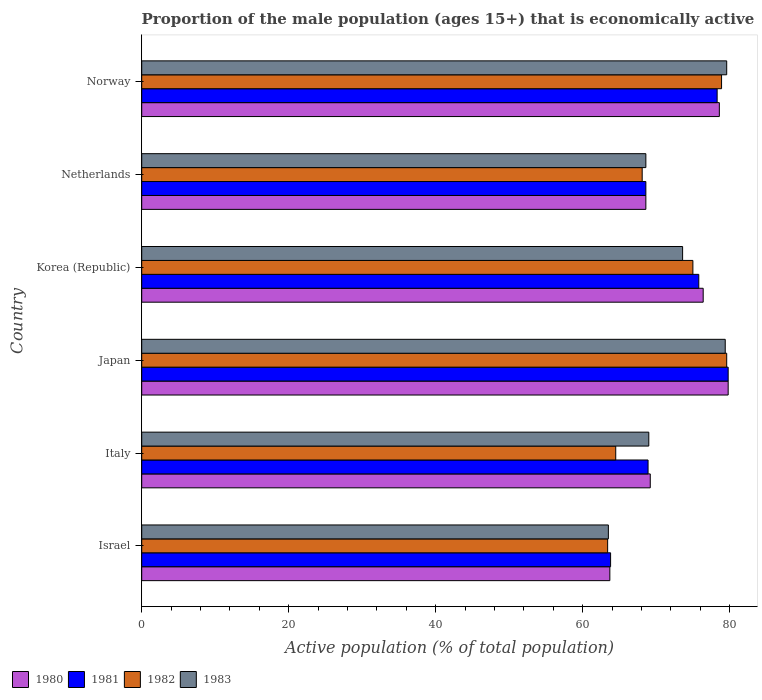How many different coloured bars are there?
Offer a very short reply. 4. Are the number of bars on each tick of the Y-axis equal?
Your answer should be compact. Yes. How many bars are there on the 3rd tick from the top?
Your response must be concise. 4. How many bars are there on the 1st tick from the bottom?
Give a very brief answer. 4. In how many cases, is the number of bars for a given country not equal to the number of legend labels?
Your response must be concise. 0. Across all countries, what is the maximum proportion of the male population that is economically active in 1982?
Give a very brief answer. 79.6. Across all countries, what is the minimum proportion of the male population that is economically active in 1982?
Provide a succinct answer. 63.4. In which country was the proportion of the male population that is economically active in 1983 maximum?
Your response must be concise. Norway. In which country was the proportion of the male population that is economically active in 1982 minimum?
Ensure brevity in your answer.  Israel. What is the total proportion of the male population that is economically active in 1983 in the graph?
Offer a very short reply. 433.7. What is the difference between the proportion of the male population that is economically active in 1980 in Japan and that in Korea (Republic)?
Make the answer very short. 3.4. What is the difference between the proportion of the male population that is economically active in 1981 in Israel and the proportion of the male population that is economically active in 1980 in Norway?
Provide a succinct answer. -14.8. What is the average proportion of the male population that is economically active in 1981 per country?
Your answer should be very brief. 72.53. In how many countries, is the proportion of the male population that is economically active in 1981 greater than 4 %?
Give a very brief answer. 6. What is the ratio of the proportion of the male population that is economically active in 1981 in Netherlands to that in Norway?
Make the answer very short. 0.88. Is the difference between the proportion of the male population that is economically active in 1980 in Israel and Italy greater than the difference between the proportion of the male population that is economically active in 1982 in Israel and Italy?
Provide a succinct answer. No. What is the difference between the highest and the second highest proportion of the male population that is economically active in 1980?
Your response must be concise. 1.2. What is the difference between the highest and the lowest proportion of the male population that is economically active in 1980?
Offer a terse response. 16.1. In how many countries, is the proportion of the male population that is economically active in 1983 greater than the average proportion of the male population that is economically active in 1983 taken over all countries?
Offer a very short reply. 3. Is the sum of the proportion of the male population that is economically active in 1982 in Italy and Japan greater than the maximum proportion of the male population that is economically active in 1981 across all countries?
Offer a terse response. Yes. Is it the case that in every country, the sum of the proportion of the male population that is economically active in 1981 and proportion of the male population that is economically active in 1980 is greater than the sum of proportion of the male population that is economically active in 1982 and proportion of the male population that is economically active in 1983?
Your response must be concise. No. Are all the bars in the graph horizontal?
Provide a succinct answer. Yes. What is the title of the graph?
Offer a terse response. Proportion of the male population (ages 15+) that is economically active. What is the label or title of the X-axis?
Keep it short and to the point. Active population (% of total population). What is the Active population (% of total population) in 1980 in Israel?
Your response must be concise. 63.7. What is the Active population (% of total population) in 1981 in Israel?
Your answer should be compact. 63.8. What is the Active population (% of total population) of 1982 in Israel?
Ensure brevity in your answer.  63.4. What is the Active population (% of total population) of 1983 in Israel?
Keep it short and to the point. 63.5. What is the Active population (% of total population) of 1980 in Italy?
Provide a short and direct response. 69.2. What is the Active population (% of total population) in 1981 in Italy?
Give a very brief answer. 68.9. What is the Active population (% of total population) of 1982 in Italy?
Keep it short and to the point. 64.5. What is the Active population (% of total population) of 1983 in Italy?
Your answer should be very brief. 69. What is the Active population (% of total population) of 1980 in Japan?
Your response must be concise. 79.8. What is the Active population (% of total population) in 1981 in Japan?
Give a very brief answer. 79.8. What is the Active population (% of total population) in 1982 in Japan?
Your answer should be very brief. 79.6. What is the Active population (% of total population) in 1983 in Japan?
Keep it short and to the point. 79.4. What is the Active population (% of total population) in 1980 in Korea (Republic)?
Make the answer very short. 76.4. What is the Active population (% of total population) in 1981 in Korea (Republic)?
Offer a very short reply. 75.8. What is the Active population (% of total population) in 1983 in Korea (Republic)?
Offer a terse response. 73.6. What is the Active population (% of total population) in 1980 in Netherlands?
Provide a succinct answer. 68.6. What is the Active population (% of total population) of 1981 in Netherlands?
Your answer should be compact. 68.6. What is the Active population (% of total population) of 1982 in Netherlands?
Offer a very short reply. 68.1. What is the Active population (% of total population) in 1983 in Netherlands?
Provide a short and direct response. 68.6. What is the Active population (% of total population) in 1980 in Norway?
Ensure brevity in your answer.  78.6. What is the Active population (% of total population) in 1981 in Norway?
Make the answer very short. 78.3. What is the Active population (% of total population) of 1982 in Norway?
Offer a very short reply. 78.9. What is the Active population (% of total population) of 1983 in Norway?
Your response must be concise. 79.6. Across all countries, what is the maximum Active population (% of total population) in 1980?
Your answer should be very brief. 79.8. Across all countries, what is the maximum Active population (% of total population) of 1981?
Make the answer very short. 79.8. Across all countries, what is the maximum Active population (% of total population) of 1982?
Keep it short and to the point. 79.6. Across all countries, what is the maximum Active population (% of total population) in 1983?
Provide a short and direct response. 79.6. Across all countries, what is the minimum Active population (% of total population) in 1980?
Give a very brief answer. 63.7. Across all countries, what is the minimum Active population (% of total population) of 1981?
Your answer should be compact. 63.8. Across all countries, what is the minimum Active population (% of total population) in 1982?
Your response must be concise. 63.4. Across all countries, what is the minimum Active population (% of total population) of 1983?
Make the answer very short. 63.5. What is the total Active population (% of total population) of 1980 in the graph?
Provide a succinct answer. 436.3. What is the total Active population (% of total population) in 1981 in the graph?
Provide a succinct answer. 435.2. What is the total Active population (% of total population) of 1982 in the graph?
Offer a terse response. 429.5. What is the total Active population (% of total population) in 1983 in the graph?
Offer a very short reply. 433.7. What is the difference between the Active population (% of total population) in 1980 in Israel and that in Italy?
Keep it short and to the point. -5.5. What is the difference between the Active population (% of total population) in 1983 in Israel and that in Italy?
Offer a terse response. -5.5. What is the difference between the Active population (% of total population) of 1980 in Israel and that in Japan?
Make the answer very short. -16.1. What is the difference between the Active population (% of total population) of 1981 in Israel and that in Japan?
Offer a very short reply. -16. What is the difference between the Active population (% of total population) of 1982 in Israel and that in Japan?
Make the answer very short. -16.2. What is the difference between the Active population (% of total population) in 1983 in Israel and that in Japan?
Ensure brevity in your answer.  -15.9. What is the difference between the Active population (% of total population) in 1981 in Israel and that in Korea (Republic)?
Offer a very short reply. -12. What is the difference between the Active population (% of total population) in 1983 in Israel and that in Korea (Republic)?
Provide a succinct answer. -10.1. What is the difference between the Active population (% of total population) of 1983 in Israel and that in Netherlands?
Offer a very short reply. -5.1. What is the difference between the Active population (% of total population) in 1980 in Israel and that in Norway?
Give a very brief answer. -14.9. What is the difference between the Active population (% of total population) in 1982 in Israel and that in Norway?
Your response must be concise. -15.5. What is the difference between the Active population (% of total population) in 1983 in Israel and that in Norway?
Provide a short and direct response. -16.1. What is the difference between the Active population (% of total population) of 1980 in Italy and that in Japan?
Keep it short and to the point. -10.6. What is the difference between the Active population (% of total population) of 1982 in Italy and that in Japan?
Provide a succinct answer. -15.1. What is the difference between the Active population (% of total population) of 1980 in Italy and that in Korea (Republic)?
Provide a short and direct response. -7.2. What is the difference between the Active population (% of total population) of 1981 in Italy and that in Korea (Republic)?
Provide a succinct answer. -6.9. What is the difference between the Active population (% of total population) of 1983 in Italy and that in Korea (Republic)?
Offer a terse response. -4.6. What is the difference between the Active population (% of total population) in 1980 in Italy and that in Netherlands?
Give a very brief answer. 0.6. What is the difference between the Active population (% of total population) of 1982 in Italy and that in Netherlands?
Provide a succinct answer. -3.6. What is the difference between the Active population (% of total population) of 1983 in Italy and that in Netherlands?
Your answer should be very brief. 0.4. What is the difference between the Active population (% of total population) in 1980 in Italy and that in Norway?
Your answer should be compact. -9.4. What is the difference between the Active population (% of total population) in 1981 in Italy and that in Norway?
Give a very brief answer. -9.4. What is the difference between the Active population (% of total population) in 1982 in Italy and that in Norway?
Make the answer very short. -14.4. What is the difference between the Active population (% of total population) in 1980 in Japan and that in Korea (Republic)?
Your answer should be very brief. 3.4. What is the difference between the Active population (% of total population) in 1981 in Japan and that in Korea (Republic)?
Your answer should be very brief. 4. What is the difference between the Active population (% of total population) in 1982 in Japan and that in Korea (Republic)?
Keep it short and to the point. 4.6. What is the difference between the Active population (% of total population) of 1983 in Japan and that in Korea (Republic)?
Provide a short and direct response. 5.8. What is the difference between the Active population (% of total population) in 1980 in Japan and that in Netherlands?
Provide a short and direct response. 11.2. What is the difference between the Active population (% of total population) of 1982 in Japan and that in Netherlands?
Provide a succinct answer. 11.5. What is the difference between the Active population (% of total population) of 1983 in Japan and that in Netherlands?
Your response must be concise. 10.8. What is the difference between the Active population (% of total population) in 1981 in Japan and that in Norway?
Give a very brief answer. 1.5. What is the difference between the Active population (% of total population) in 1983 in Japan and that in Norway?
Offer a very short reply. -0.2. What is the difference between the Active population (% of total population) in 1980 in Korea (Republic) and that in Netherlands?
Provide a succinct answer. 7.8. What is the difference between the Active population (% of total population) of 1981 in Korea (Republic) and that in Netherlands?
Ensure brevity in your answer.  7.2. What is the difference between the Active population (% of total population) of 1982 in Korea (Republic) and that in Netherlands?
Offer a terse response. 6.9. What is the difference between the Active population (% of total population) in 1981 in Korea (Republic) and that in Norway?
Give a very brief answer. -2.5. What is the difference between the Active population (% of total population) in 1980 in Netherlands and that in Norway?
Offer a terse response. -10. What is the difference between the Active population (% of total population) in 1980 in Israel and the Active population (% of total population) in 1981 in Italy?
Give a very brief answer. -5.2. What is the difference between the Active population (% of total population) in 1980 in Israel and the Active population (% of total population) in 1982 in Italy?
Ensure brevity in your answer.  -0.8. What is the difference between the Active population (% of total population) in 1980 in Israel and the Active population (% of total population) in 1983 in Italy?
Provide a succinct answer. -5.3. What is the difference between the Active population (% of total population) of 1981 in Israel and the Active population (% of total population) of 1982 in Italy?
Offer a terse response. -0.7. What is the difference between the Active population (% of total population) of 1981 in Israel and the Active population (% of total population) of 1983 in Italy?
Ensure brevity in your answer.  -5.2. What is the difference between the Active population (% of total population) in 1980 in Israel and the Active population (% of total population) in 1981 in Japan?
Offer a terse response. -16.1. What is the difference between the Active population (% of total population) in 1980 in Israel and the Active population (% of total population) in 1982 in Japan?
Provide a succinct answer. -15.9. What is the difference between the Active population (% of total population) in 1980 in Israel and the Active population (% of total population) in 1983 in Japan?
Provide a short and direct response. -15.7. What is the difference between the Active population (% of total population) of 1981 in Israel and the Active population (% of total population) of 1982 in Japan?
Your answer should be compact. -15.8. What is the difference between the Active population (% of total population) of 1981 in Israel and the Active population (% of total population) of 1983 in Japan?
Your answer should be very brief. -15.6. What is the difference between the Active population (% of total population) of 1980 in Israel and the Active population (% of total population) of 1982 in Korea (Republic)?
Your answer should be compact. -11.3. What is the difference between the Active population (% of total population) in 1981 in Israel and the Active population (% of total population) in 1982 in Korea (Republic)?
Provide a short and direct response. -11.2. What is the difference between the Active population (% of total population) in 1980 in Israel and the Active population (% of total population) in 1981 in Netherlands?
Your answer should be compact. -4.9. What is the difference between the Active population (% of total population) of 1981 in Israel and the Active population (% of total population) of 1982 in Netherlands?
Provide a short and direct response. -4.3. What is the difference between the Active population (% of total population) of 1981 in Israel and the Active population (% of total population) of 1983 in Netherlands?
Provide a succinct answer. -4.8. What is the difference between the Active population (% of total population) in 1982 in Israel and the Active population (% of total population) in 1983 in Netherlands?
Keep it short and to the point. -5.2. What is the difference between the Active population (% of total population) in 1980 in Israel and the Active population (% of total population) in 1981 in Norway?
Your answer should be very brief. -14.6. What is the difference between the Active population (% of total population) in 1980 in Israel and the Active population (% of total population) in 1982 in Norway?
Provide a succinct answer. -15.2. What is the difference between the Active population (% of total population) of 1980 in Israel and the Active population (% of total population) of 1983 in Norway?
Provide a short and direct response. -15.9. What is the difference between the Active population (% of total population) in 1981 in Israel and the Active population (% of total population) in 1982 in Norway?
Your answer should be very brief. -15.1. What is the difference between the Active population (% of total population) of 1981 in Israel and the Active population (% of total population) of 1983 in Norway?
Ensure brevity in your answer.  -15.8. What is the difference between the Active population (% of total population) in 1982 in Israel and the Active population (% of total population) in 1983 in Norway?
Your answer should be very brief. -16.2. What is the difference between the Active population (% of total population) of 1980 in Italy and the Active population (% of total population) of 1981 in Japan?
Provide a short and direct response. -10.6. What is the difference between the Active population (% of total population) in 1982 in Italy and the Active population (% of total population) in 1983 in Japan?
Offer a very short reply. -14.9. What is the difference between the Active population (% of total population) of 1980 in Italy and the Active population (% of total population) of 1981 in Korea (Republic)?
Offer a very short reply. -6.6. What is the difference between the Active population (% of total population) of 1980 in Italy and the Active population (% of total population) of 1982 in Korea (Republic)?
Your response must be concise. -5.8. What is the difference between the Active population (% of total population) in 1980 in Italy and the Active population (% of total population) in 1983 in Korea (Republic)?
Your answer should be compact. -4.4. What is the difference between the Active population (% of total population) of 1981 in Italy and the Active population (% of total population) of 1983 in Korea (Republic)?
Keep it short and to the point. -4.7. What is the difference between the Active population (% of total population) of 1982 in Italy and the Active population (% of total population) of 1983 in Korea (Republic)?
Provide a succinct answer. -9.1. What is the difference between the Active population (% of total population) in 1980 in Italy and the Active population (% of total population) in 1981 in Netherlands?
Make the answer very short. 0.6. What is the difference between the Active population (% of total population) of 1981 in Italy and the Active population (% of total population) of 1983 in Netherlands?
Your response must be concise. 0.3. What is the difference between the Active population (% of total population) of 1980 in Italy and the Active population (% of total population) of 1981 in Norway?
Your answer should be compact. -9.1. What is the difference between the Active population (% of total population) in 1980 in Italy and the Active population (% of total population) in 1983 in Norway?
Provide a short and direct response. -10.4. What is the difference between the Active population (% of total population) in 1981 in Italy and the Active population (% of total population) in 1983 in Norway?
Give a very brief answer. -10.7. What is the difference between the Active population (% of total population) of 1982 in Italy and the Active population (% of total population) of 1983 in Norway?
Keep it short and to the point. -15.1. What is the difference between the Active population (% of total population) of 1980 in Japan and the Active population (% of total population) of 1981 in Korea (Republic)?
Offer a very short reply. 4. What is the difference between the Active population (% of total population) in 1980 in Japan and the Active population (% of total population) in 1982 in Korea (Republic)?
Your response must be concise. 4.8. What is the difference between the Active population (% of total population) in 1980 in Japan and the Active population (% of total population) in 1983 in Korea (Republic)?
Give a very brief answer. 6.2. What is the difference between the Active population (% of total population) of 1981 in Japan and the Active population (% of total population) of 1982 in Korea (Republic)?
Provide a short and direct response. 4.8. What is the difference between the Active population (% of total population) of 1981 in Japan and the Active population (% of total population) of 1983 in Korea (Republic)?
Provide a short and direct response. 6.2. What is the difference between the Active population (% of total population) of 1982 in Japan and the Active population (% of total population) of 1983 in Korea (Republic)?
Provide a short and direct response. 6. What is the difference between the Active population (% of total population) of 1980 in Japan and the Active population (% of total population) of 1981 in Netherlands?
Offer a terse response. 11.2. What is the difference between the Active population (% of total population) in 1980 in Japan and the Active population (% of total population) in 1982 in Netherlands?
Your response must be concise. 11.7. What is the difference between the Active population (% of total population) in 1980 in Japan and the Active population (% of total population) in 1983 in Netherlands?
Make the answer very short. 11.2. What is the difference between the Active population (% of total population) in 1981 in Japan and the Active population (% of total population) in 1982 in Netherlands?
Provide a succinct answer. 11.7. What is the difference between the Active population (% of total population) of 1980 in Japan and the Active population (% of total population) of 1981 in Norway?
Provide a short and direct response. 1.5. What is the difference between the Active population (% of total population) of 1980 in Japan and the Active population (% of total population) of 1982 in Norway?
Give a very brief answer. 0.9. What is the difference between the Active population (% of total population) of 1981 in Japan and the Active population (% of total population) of 1982 in Norway?
Make the answer very short. 0.9. What is the difference between the Active population (% of total population) in 1981 in Japan and the Active population (% of total population) in 1983 in Norway?
Ensure brevity in your answer.  0.2. What is the difference between the Active population (% of total population) in 1982 in Japan and the Active population (% of total population) in 1983 in Norway?
Ensure brevity in your answer.  0. What is the difference between the Active population (% of total population) in 1980 in Korea (Republic) and the Active population (% of total population) in 1981 in Netherlands?
Make the answer very short. 7.8. What is the difference between the Active population (% of total population) in 1981 in Korea (Republic) and the Active population (% of total population) in 1983 in Netherlands?
Offer a terse response. 7.2. What is the difference between the Active population (% of total population) of 1980 in Korea (Republic) and the Active population (% of total population) of 1981 in Norway?
Make the answer very short. -1.9. What is the difference between the Active population (% of total population) of 1980 in Netherlands and the Active population (% of total population) of 1982 in Norway?
Your answer should be compact. -10.3. What is the difference between the Active population (% of total population) in 1982 in Netherlands and the Active population (% of total population) in 1983 in Norway?
Make the answer very short. -11.5. What is the average Active population (% of total population) of 1980 per country?
Your answer should be compact. 72.72. What is the average Active population (% of total population) of 1981 per country?
Your response must be concise. 72.53. What is the average Active population (% of total population) of 1982 per country?
Your response must be concise. 71.58. What is the average Active population (% of total population) in 1983 per country?
Offer a very short reply. 72.28. What is the difference between the Active population (% of total population) of 1981 and Active population (% of total population) of 1983 in Israel?
Offer a very short reply. 0.3. What is the difference between the Active population (% of total population) of 1982 and Active population (% of total population) of 1983 in Israel?
Your answer should be very brief. -0.1. What is the difference between the Active population (% of total population) of 1980 and Active population (% of total population) of 1982 in Italy?
Ensure brevity in your answer.  4.7. What is the difference between the Active population (% of total population) of 1980 and Active population (% of total population) of 1983 in Italy?
Keep it short and to the point. 0.2. What is the difference between the Active population (% of total population) of 1982 and Active population (% of total population) of 1983 in Italy?
Make the answer very short. -4.5. What is the difference between the Active population (% of total population) of 1980 and Active population (% of total population) of 1981 in Japan?
Make the answer very short. 0. What is the difference between the Active population (% of total population) in 1980 and Active population (% of total population) in 1983 in Japan?
Keep it short and to the point. 0.4. What is the difference between the Active population (% of total population) in 1981 and Active population (% of total population) in 1982 in Japan?
Your response must be concise. 0.2. What is the difference between the Active population (% of total population) in 1982 and Active population (% of total population) in 1983 in Japan?
Keep it short and to the point. 0.2. What is the difference between the Active population (% of total population) in 1981 and Active population (% of total population) in 1983 in Korea (Republic)?
Ensure brevity in your answer.  2.2. What is the difference between the Active population (% of total population) in 1980 and Active population (% of total population) in 1981 in Netherlands?
Provide a succinct answer. 0. What is the difference between the Active population (% of total population) in 1980 and Active population (% of total population) in 1982 in Netherlands?
Your answer should be compact. 0.5. What is the difference between the Active population (% of total population) of 1981 and Active population (% of total population) of 1982 in Netherlands?
Give a very brief answer. 0.5. What is the difference between the Active population (% of total population) in 1982 and Active population (% of total population) in 1983 in Netherlands?
Offer a terse response. -0.5. What is the difference between the Active population (% of total population) in 1980 and Active population (% of total population) in 1981 in Norway?
Your answer should be compact. 0.3. What is the difference between the Active population (% of total population) in 1981 and Active population (% of total population) in 1983 in Norway?
Ensure brevity in your answer.  -1.3. What is the difference between the Active population (% of total population) in 1982 and Active population (% of total population) in 1983 in Norway?
Your answer should be very brief. -0.7. What is the ratio of the Active population (% of total population) in 1980 in Israel to that in Italy?
Your answer should be compact. 0.92. What is the ratio of the Active population (% of total population) in 1981 in Israel to that in Italy?
Offer a terse response. 0.93. What is the ratio of the Active population (% of total population) of 1982 in Israel to that in Italy?
Give a very brief answer. 0.98. What is the ratio of the Active population (% of total population) of 1983 in Israel to that in Italy?
Give a very brief answer. 0.92. What is the ratio of the Active population (% of total population) in 1980 in Israel to that in Japan?
Keep it short and to the point. 0.8. What is the ratio of the Active population (% of total population) of 1981 in Israel to that in Japan?
Keep it short and to the point. 0.8. What is the ratio of the Active population (% of total population) of 1982 in Israel to that in Japan?
Your response must be concise. 0.8. What is the ratio of the Active population (% of total population) of 1983 in Israel to that in Japan?
Provide a succinct answer. 0.8. What is the ratio of the Active population (% of total population) in 1980 in Israel to that in Korea (Republic)?
Give a very brief answer. 0.83. What is the ratio of the Active population (% of total population) in 1981 in Israel to that in Korea (Republic)?
Keep it short and to the point. 0.84. What is the ratio of the Active population (% of total population) of 1982 in Israel to that in Korea (Republic)?
Ensure brevity in your answer.  0.85. What is the ratio of the Active population (% of total population) of 1983 in Israel to that in Korea (Republic)?
Offer a very short reply. 0.86. What is the ratio of the Active population (% of total population) of 1983 in Israel to that in Netherlands?
Provide a succinct answer. 0.93. What is the ratio of the Active population (% of total population) in 1980 in Israel to that in Norway?
Your response must be concise. 0.81. What is the ratio of the Active population (% of total population) in 1981 in Israel to that in Norway?
Your answer should be compact. 0.81. What is the ratio of the Active population (% of total population) in 1982 in Israel to that in Norway?
Your response must be concise. 0.8. What is the ratio of the Active population (% of total population) in 1983 in Israel to that in Norway?
Offer a very short reply. 0.8. What is the ratio of the Active population (% of total population) of 1980 in Italy to that in Japan?
Give a very brief answer. 0.87. What is the ratio of the Active population (% of total population) in 1981 in Italy to that in Japan?
Make the answer very short. 0.86. What is the ratio of the Active population (% of total population) in 1982 in Italy to that in Japan?
Make the answer very short. 0.81. What is the ratio of the Active population (% of total population) of 1983 in Italy to that in Japan?
Keep it short and to the point. 0.87. What is the ratio of the Active population (% of total population) of 1980 in Italy to that in Korea (Republic)?
Offer a terse response. 0.91. What is the ratio of the Active population (% of total population) of 1981 in Italy to that in Korea (Republic)?
Offer a very short reply. 0.91. What is the ratio of the Active population (% of total population) in 1982 in Italy to that in Korea (Republic)?
Ensure brevity in your answer.  0.86. What is the ratio of the Active population (% of total population) in 1983 in Italy to that in Korea (Republic)?
Your response must be concise. 0.94. What is the ratio of the Active population (% of total population) of 1980 in Italy to that in Netherlands?
Your answer should be compact. 1.01. What is the ratio of the Active population (% of total population) in 1981 in Italy to that in Netherlands?
Provide a succinct answer. 1. What is the ratio of the Active population (% of total population) of 1982 in Italy to that in Netherlands?
Provide a succinct answer. 0.95. What is the ratio of the Active population (% of total population) of 1983 in Italy to that in Netherlands?
Your answer should be compact. 1.01. What is the ratio of the Active population (% of total population) of 1980 in Italy to that in Norway?
Your answer should be compact. 0.88. What is the ratio of the Active population (% of total population) of 1981 in Italy to that in Norway?
Provide a short and direct response. 0.88. What is the ratio of the Active population (% of total population) of 1982 in Italy to that in Norway?
Offer a terse response. 0.82. What is the ratio of the Active population (% of total population) in 1983 in Italy to that in Norway?
Offer a very short reply. 0.87. What is the ratio of the Active population (% of total population) of 1980 in Japan to that in Korea (Republic)?
Offer a very short reply. 1.04. What is the ratio of the Active population (% of total population) of 1981 in Japan to that in Korea (Republic)?
Ensure brevity in your answer.  1.05. What is the ratio of the Active population (% of total population) of 1982 in Japan to that in Korea (Republic)?
Give a very brief answer. 1.06. What is the ratio of the Active population (% of total population) of 1983 in Japan to that in Korea (Republic)?
Your response must be concise. 1.08. What is the ratio of the Active population (% of total population) in 1980 in Japan to that in Netherlands?
Give a very brief answer. 1.16. What is the ratio of the Active population (% of total population) in 1981 in Japan to that in Netherlands?
Your response must be concise. 1.16. What is the ratio of the Active population (% of total population) in 1982 in Japan to that in Netherlands?
Ensure brevity in your answer.  1.17. What is the ratio of the Active population (% of total population) of 1983 in Japan to that in Netherlands?
Your answer should be compact. 1.16. What is the ratio of the Active population (% of total population) of 1980 in Japan to that in Norway?
Your response must be concise. 1.02. What is the ratio of the Active population (% of total population) in 1981 in Japan to that in Norway?
Provide a short and direct response. 1.02. What is the ratio of the Active population (% of total population) in 1982 in Japan to that in Norway?
Offer a very short reply. 1.01. What is the ratio of the Active population (% of total population) in 1980 in Korea (Republic) to that in Netherlands?
Offer a very short reply. 1.11. What is the ratio of the Active population (% of total population) in 1981 in Korea (Republic) to that in Netherlands?
Your answer should be very brief. 1.1. What is the ratio of the Active population (% of total population) of 1982 in Korea (Republic) to that in Netherlands?
Your answer should be very brief. 1.1. What is the ratio of the Active population (% of total population) in 1983 in Korea (Republic) to that in Netherlands?
Your response must be concise. 1.07. What is the ratio of the Active population (% of total population) of 1980 in Korea (Republic) to that in Norway?
Offer a terse response. 0.97. What is the ratio of the Active population (% of total population) of 1981 in Korea (Republic) to that in Norway?
Your answer should be compact. 0.97. What is the ratio of the Active population (% of total population) of 1982 in Korea (Republic) to that in Norway?
Make the answer very short. 0.95. What is the ratio of the Active population (% of total population) in 1983 in Korea (Republic) to that in Norway?
Your answer should be compact. 0.92. What is the ratio of the Active population (% of total population) in 1980 in Netherlands to that in Norway?
Provide a succinct answer. 0.87. What is the ratio of the Active population (% of total population) of 1981 in Netherlands to that in Norway?
Provide a short and direct response. 0.88. What is the ratio of the Active population (% of total population) of 1982 in Netherlands to that in Norway?
Provide a short and direct response. 0.86. What is the ratio of the Active population (% of total population) in 1983 in Netherlands to that in Norway?
Your answer should be compact. 0.86. What is the difference between the highest and the second highest Active population (% of total population) in 1981?
Your response must be concise. 1.5. What is the difference between the highest and the second highest Active population (% of total population) in 1982?
Offer a terse response. 0.7. 